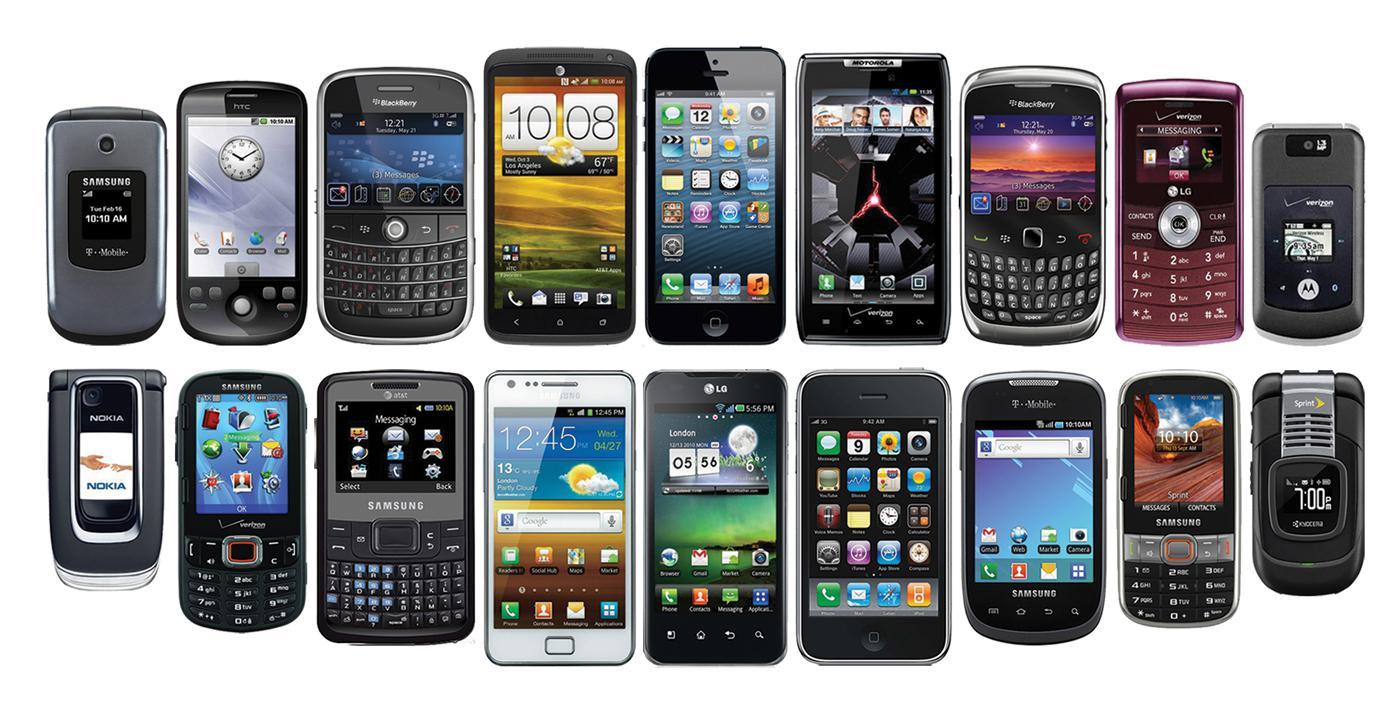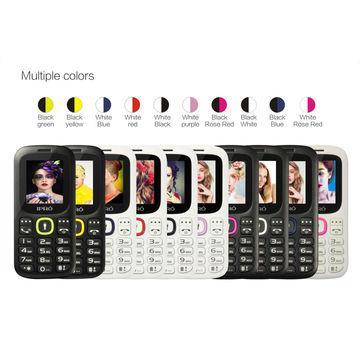The first image is the image on the left, the second image is the image on the right. For the images displayed, is the sentence "The right image contains no more than three cell phones." factually correct? Answer yes or no. No. The first image is the image on the left, the second image is the image on the right. Assess this claim about the two images: "There is a non smart phone in a charger.". Correct or not? Answer yes or no. No. 